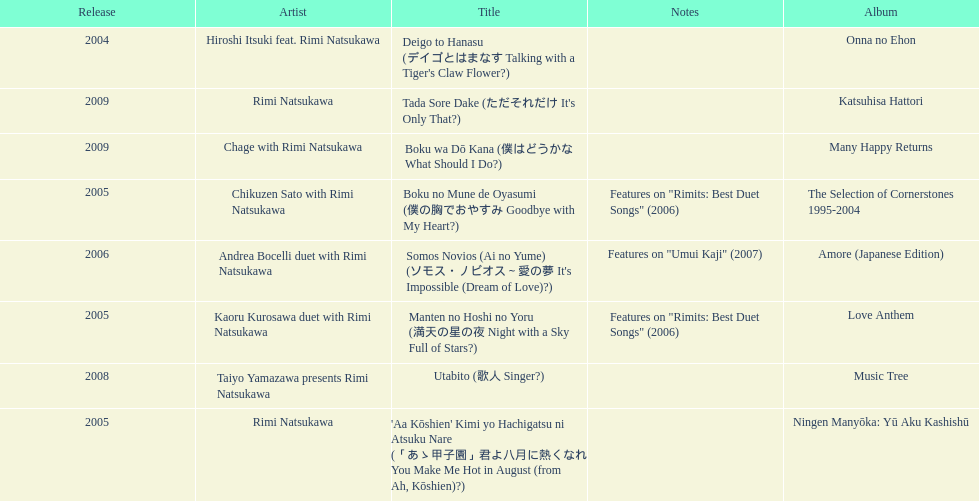Which title has the same notes as night with a sky full of stars? Boku no Mune de Oyasumi (僕の胸でおやすみ Goodbye with My Heart?). Could you help me parse every detail presented in this table? {'header': ['Release', 'Artist', 'Title', 'Notes', 'Album'], 'rows': [['2004', 'Hiroshi Itsuki feat. Rimi Natsukawa', "Deigo to Hanasu (デイゴとはまなす Talking with a Tiger's Claw Flower?)", '', 'Onna no Ehon'], ['2009', 'Rimi Natsukawa', "Tada Sore Dake (ただそれだけ It's Only That?)", '', 'Katsuhisa Hattori'], ['2009', 'Chage with Rimi Natsukawa', 'Boku wa Dō Kana (僕はどうかな What Should I Do?)', '', 'Many Happy Returns'], ['2005', 'Chikuzen Sato with Rimi Natsukawa', 'Boku no Mune de Oyasumi (僕の胸でおやすみ Goodbye with My Heart?)', 'Features on "Rimits: Best Duet Songs" (2006)', 'The Selection of Cornerstones 1995-2004'], ['2006', 'Andrea Bocelli duet with Rimi Natsukawa', "Somos Novios (Ai no Yume) (ソモス・ノビオス～愛の夢 It's Impossible (Dream of Love)?)", 'Features on "Umui Kaji" (2007)', 'Amore (Japanese Edition)'], ['2005', 'Kaoru Kurosawa duet with Rimi Natsukawa', 'Manten no Hoshi no Yoru (満天の星の夜 Night with a Sky Full of Stars?)', 'Features on "Rimits: Best Duet Songs" (2006)', 'Love Anthem'], ['2008', 'Taiyo Yamazawa presents Rimi Natsukawa', 'Utabito (歌人 Singer?)', '', 'Music Tree'], ['2005', 'Rimi Natsukawa', "'Aa Kōshien' Kimi yo Hachigatsu ni Atsuku Nare (「あゝ甲子園」君よ八月に熱くなれ You Make Me Hot in August (from Ah, Kōshien)?)", '', 'Ningen Manyōka: Yū Aku Kashishū']]} 